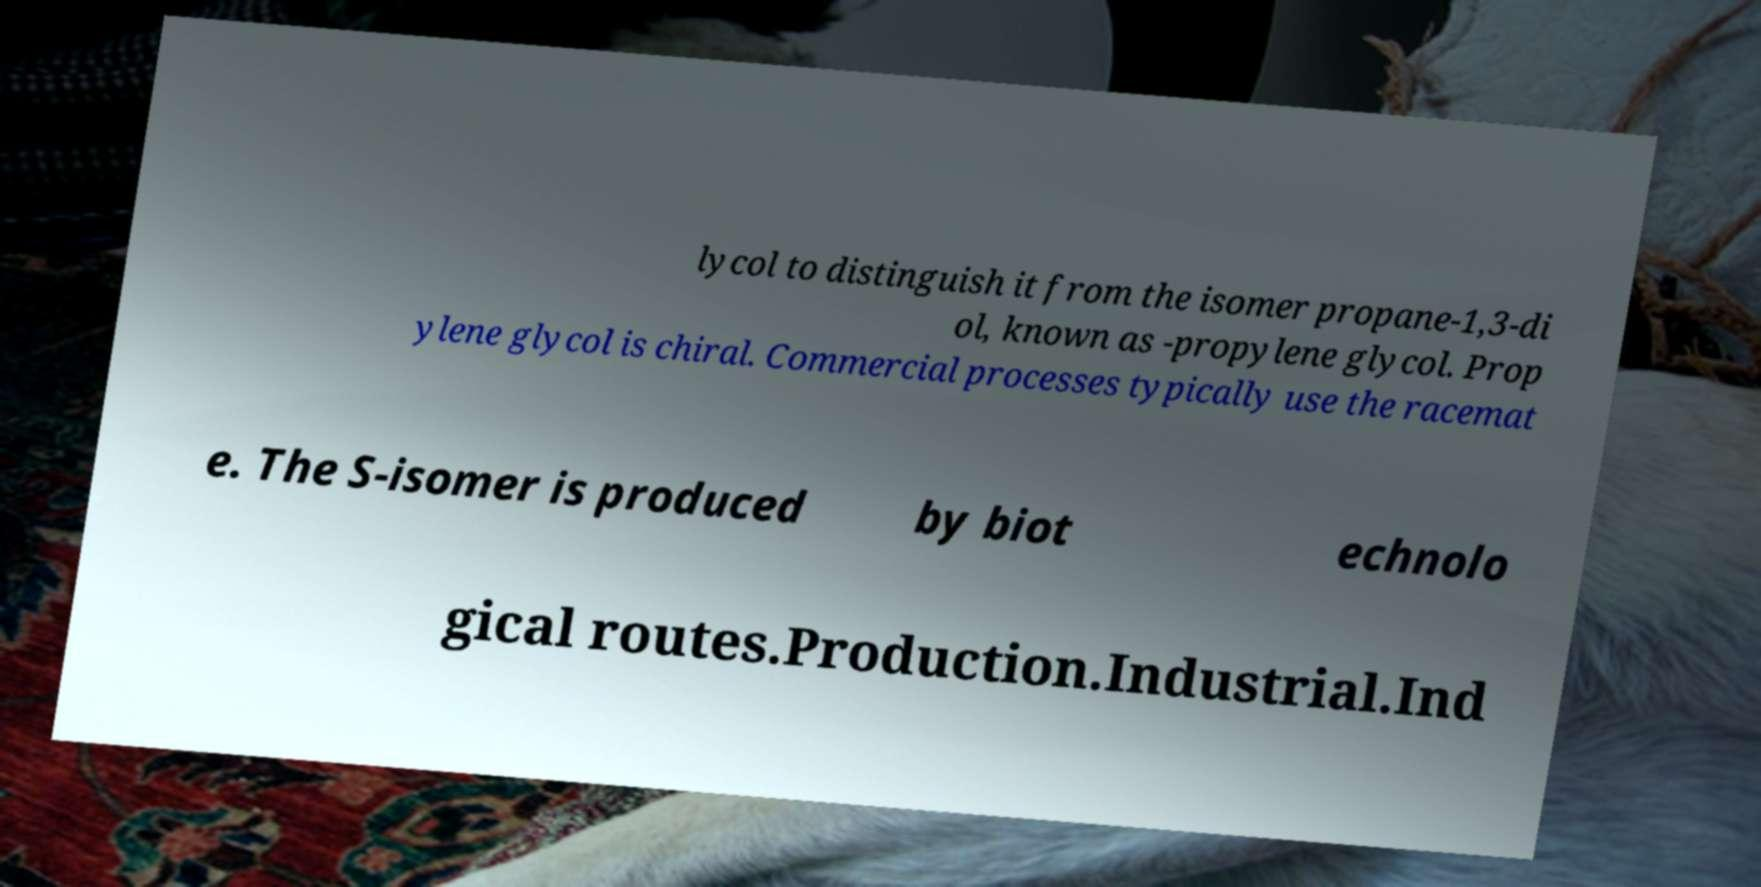I need the written content from this picture converted into text. Can you do that? lycol to distinguish it from the isomer propane-1,3-di ol, known as -propylene glycol. Prop ylene glycol is chiral. Commercial processes typically use the racemat e. The S-isomer is produced by biot echnolo gical routes.Production.Industrial.Ind 